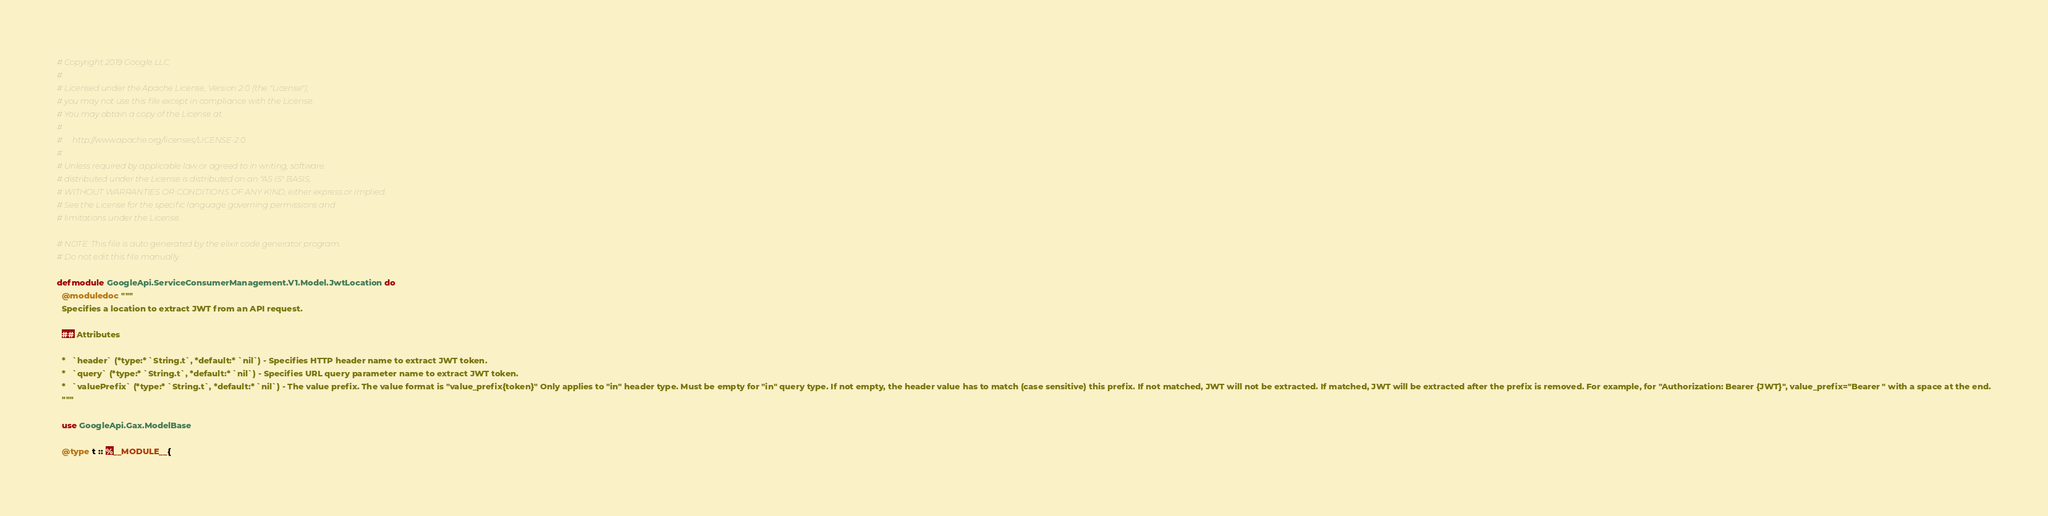<code> <loc_0><loc_0><loc_500><loc_500><_Elixir_># Copyright 2019 Google LLC
#
# Licensed under the Apache License, Version 2.0 (the "License");
# you may not use this file except in compliance with the License.
# You may obtain a copy of the License at
#
#     http://www.apache.org/licenses/LICENSE-2.0
#
# Unless required by applicable law or agreed to in writing, software
# distributed under the License is distributed on an "AS IS" BASIS,
# WITHOUT WARRANTIES OR CONDITIONS OF ANY KIND, either express or implied.
# See the License for the specific language governing permissions and
# limitations under the License.

# NOTE: This file is auto generated by the elixir code generator program.
# Do not edit this file manually.

defmodule GoogleApi.ServiceConsumerManagement.V1.Model.JwtLocation do
  @moduledoc """
  Specifies a location to extract JWT from an API request.

  ## Attributes

  *   `header` (*type:* `String.t`, *default:* `nil`) - Specifies HTTP header name to extract JWT token.
  *   `query` (*type:* `String.t`, *default:* `nil`) - Specifies URL query parameter name to extract JWT token.
  *   `valuePrefix` (*type:* `String.t`, *default:* `nil`) - The value prefix. The value format is "value_prefix{token}" Only applies to "in" header type. Must be empty for "in" query type. If not empty, the header value has to match (case sensitive) this prefix. If not matched, JWT will not be extracted. If matched, JWT will be extracted after the prefix is removed. For example, for "Authorization: Bearer {JWT}", value_prefix="Bearer " with a space at the end.
  """

  use GoogleApi.Gax.ModelBase

  @type t :: %__MODULE__{</code> 